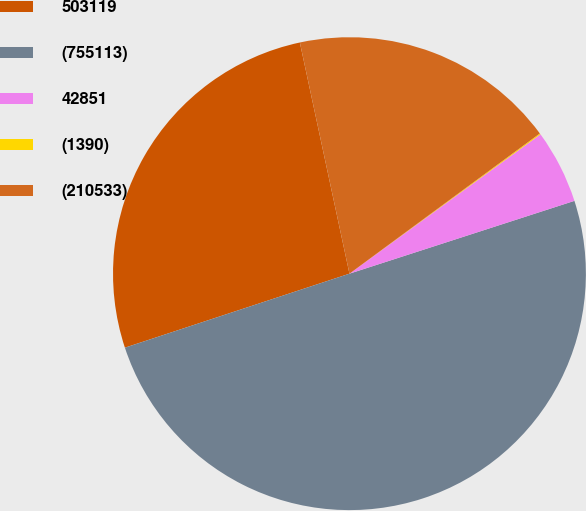<chart> <loc_0><loc_0><loc_500><loc_500><pie_chart><fcel>503119<fcel>(755113)<fcel>42851<fcel>(1390)<fcel>(210533)<nl><fcel>26.7%<fcel>49.91%<fcel>5.05%<fcel>0.07%<fcel>18.26%<nl></chart> 